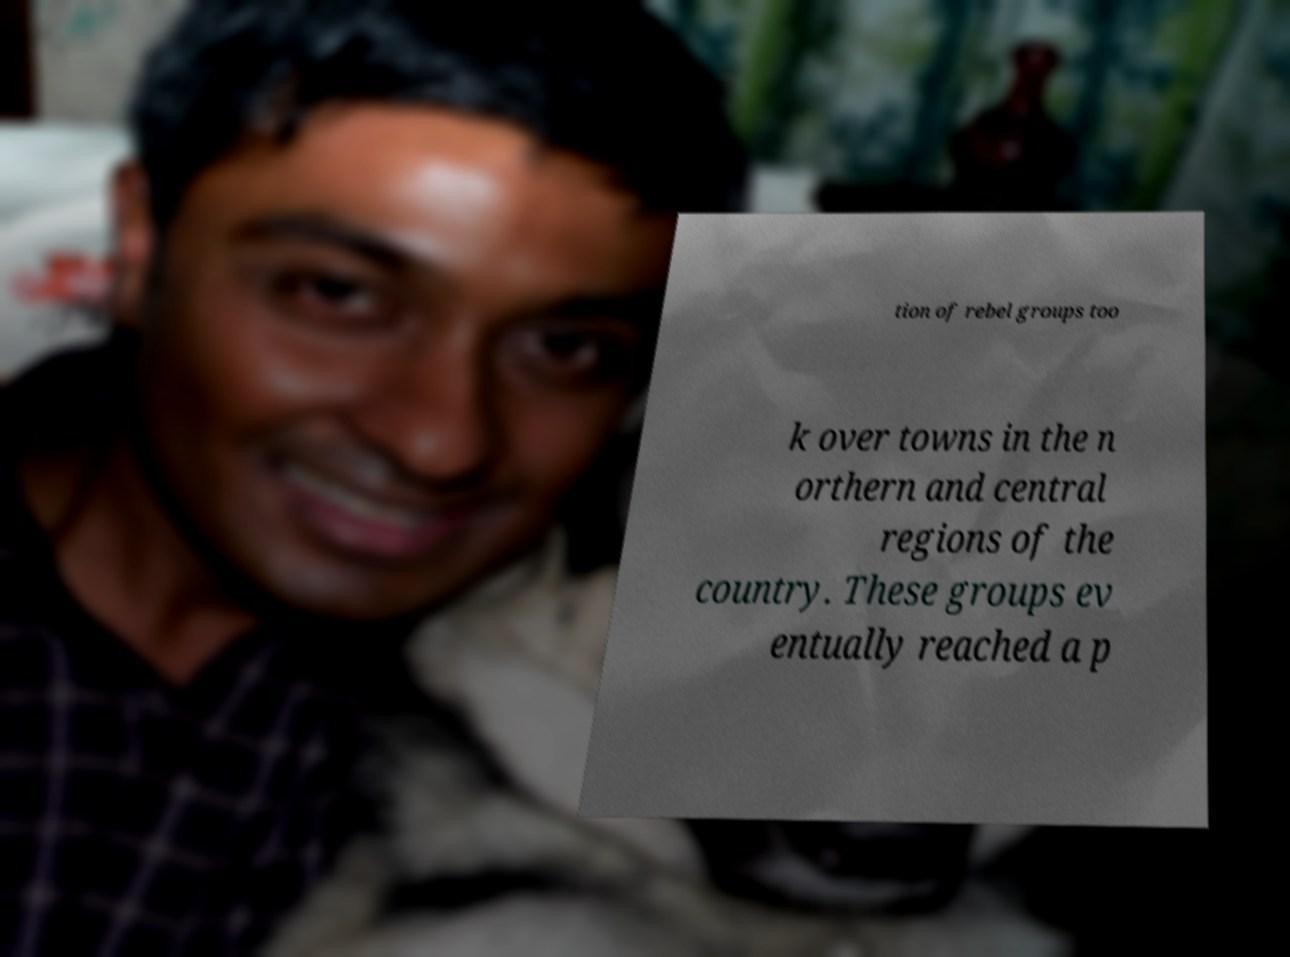Can you accurately transcribe the text from the provided image for me? tion of rebel groups too k over towns in the n orthern and central regions of the country. These groups ev entually reached a p 